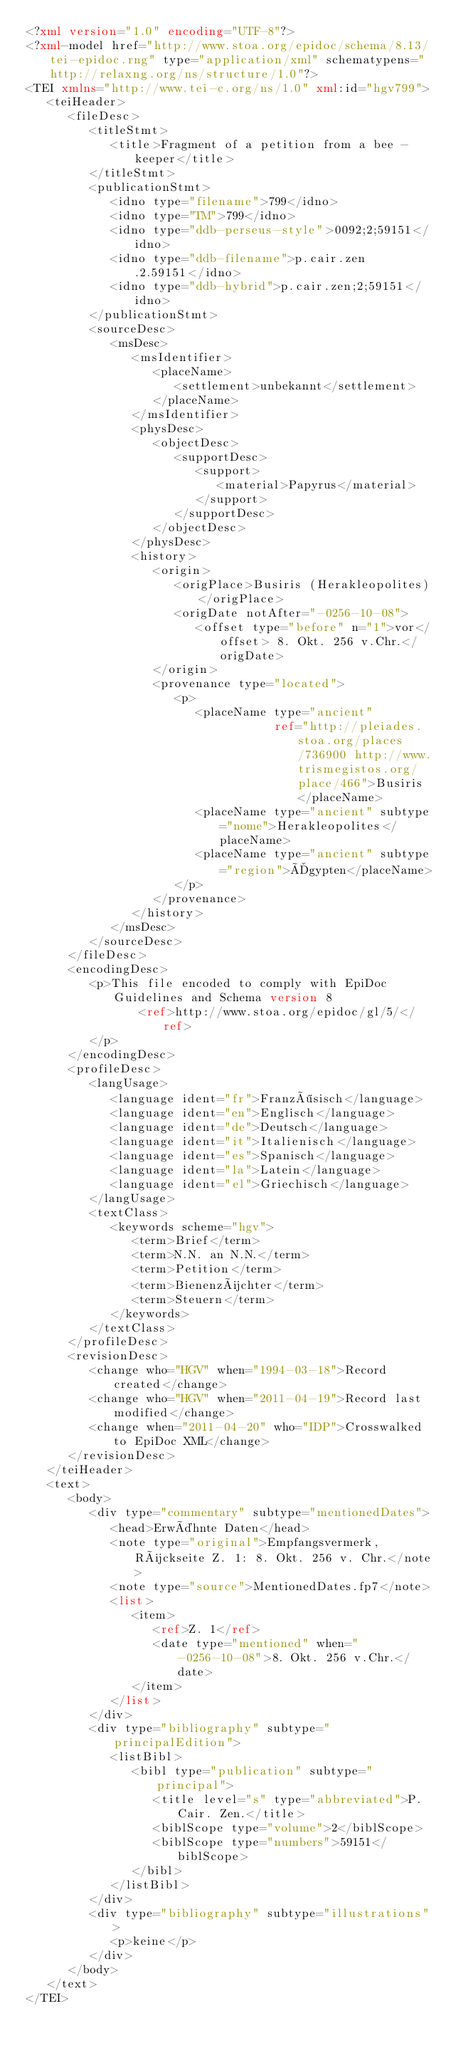<code> <loc_0><loc_0><loc_500><loc_500><_XML_><?xml version="1.0" encoding="UTF-8"?>
<?xml-model href="http://www.stoa.org/epidoc/schema/8.13/tei-epidoc.rng" type="application/xml" schematypens="http://relaxng.org/ns/structure/1.0"?>
<TEI xmlns="http://www.tei-c.org/ns/1.0" xml:id="hgv799">
   <teiHeader>
      <fileDesc>
         <titleStmt>
            <title>Fragment of a petition from a bee - keeper</title>
         </titleStmt>
         <publicationStmt>
            <idno type="filename">799</idno>
            <idno type="TM">799</idno>
            <idno type="ddb-perseus-style">0092;2;59151</idno>
            <idno type="ddb-filename">p.cair.zen.2.59151</idno>
            <idno type="ddb-hybrid">p.cair.zen;2;59151</idno>
         </publicationStmt>
         <sourceDesc>
            <msDesc>
               <msIdentifier>
                  <placeName>
                     <settlement>unbekannt</settlement>
                  </placeName>
               </msIdentifier>
               <physDesc>
                  <objectDesc>
                     <supportDesc>
                        <support>
                           <material>Papyrus</material>
                        </support>
                     </supportDesc>
                  </objectDesc>
               </physDesc>
               <history>
                  <origin>
                     <origPlace>Busiris (Herakleopolites)</origPlace>
                     <origDate notAfter="-0256-10-08">
                        <offset type="before" n="1">vor</offset> 8. Okt. 256 v.Chr.</origDate>
                  </origin>
                  <provenance type="located">
                     <p>
                        <placeName type="ancient"
                                   ref="http://pleiades.stoa.org/places/736900 http://www.trismegistos.org/place/466">Busiris</placeName>
                        <placeName type="ancient" subtype="nome">Herakleopolites</placeName>
                        <placeName type="ancient" subtype="region">Ägypten</placeName>
                     </p>
                  </provenance>
               </history>
            </msDesc>
         </sourceDesc>
      </fileDesc>
      <encodingDesc>
         <p>This file encoded to comply with EpiDoc Guidelines and Schema version 8
                <ref>http://www.stoa.org/epidoc/gl/5/</ref>
         </p>
      </encodingDesc>
      <profileDesc>
         <langUsage>
            <language ident="fr">Französisch</language>
            <language ident="en">Englisch</language>
            <language ident="de">Deutsch</language>
            <language ident="it">Italienisch</language>
            <language ident="es">Spanisch</language>
            <language ident="la">Latein</language>
            <language ident="el">Griechisch</language>
         </langUsage>
         <textClass>
            <keywords scheme="hgv">
               <term>Brief</term>
               <term>N.N. an N.N.</term>
               <term>Petition</term>
               <term>Bienenzüchter</term>
               <term>Steuern</term>
            </keywords>
         </textClass>
      </profileDesc>
      <revisionDesc>
         <change who="HGV" when="1994-03-18">Record created</change>
         <change who="HGV" when="2011-04-19">Record last modified</change>
         <change when="2011-04-20" who="IDP">Crosswalked to EpiDoc XML</change>
      </revisionDesc>
   </teiHeader>
   <text>
      <body>
         <div type="commentary" subtype="mentionedDates">
            <head>Erwähnte Daten</head>
            <note type="original">Empfangsvermerk, Rückseite Z. 1: 8. Okt. 256 v. Chr.</note>
            <note type="source">MentionedDates.fp7</note>
            <list>
               <item>
                  <ref>Z. 1</ref>
                  <date type="mentioned" when="-0256-10-08">8. Okt. 256 v.Chr.</date>
               </item>
            </list>
         </div>
         <div type="bibliography" subtype="principalEdition">
            <listBibl>
               <bibl type="publication" subtype="principal">
                  <title level="s" type="abbreviated">P.Cair. Zen.</title>
                  <biblScope type="volume">2</biblScope>
                  <biblScope type="numbers">59151</biblScope>
               </bibl>
            </listBibl>
         </div>
         <div type="bibliography" subtype="illustrations">
            <p>keine</p>
         </div>
      </body>
   </text>
</TEI>
</code> 